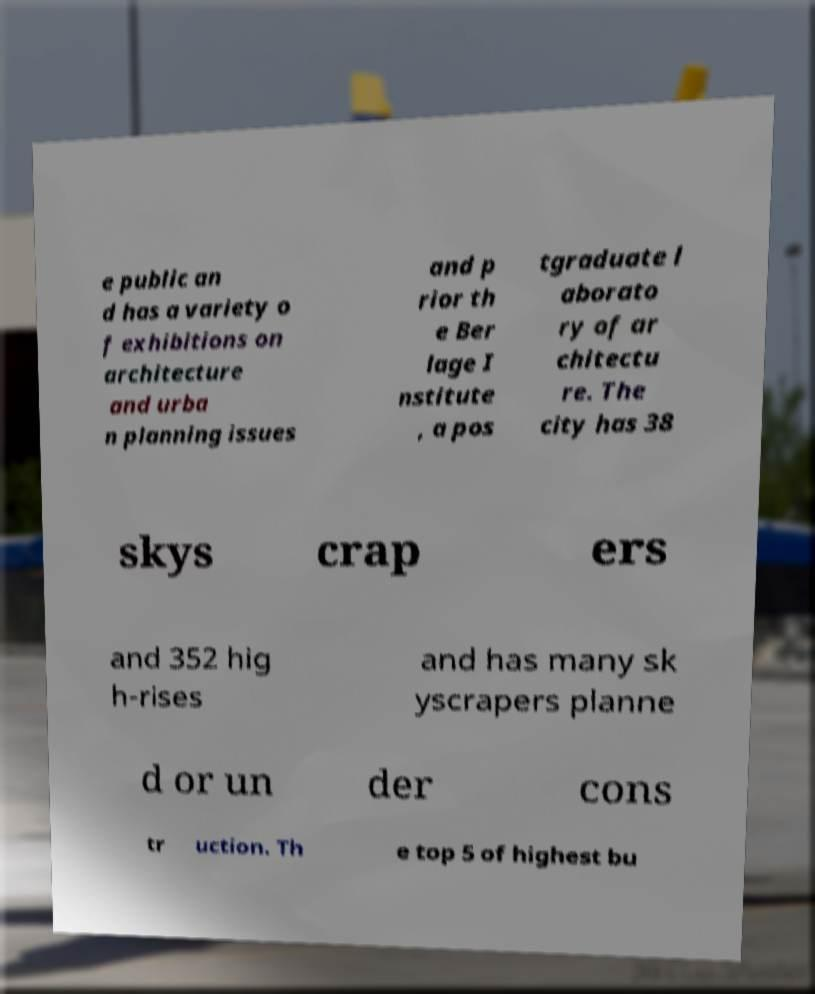Could you extract and type out the text from this image? e public an d has a variety o f exhibitions on architecture and urba n planning issues and p rior th e Ber lage I nstitute , a pos tgraduate l aborato ry of ar chitectu re. The city has 38 skys crap ers and 352 hig h-rises and has many sk yscrapers planne d or un der cons tr uction. Th e top 5 of highest bu 